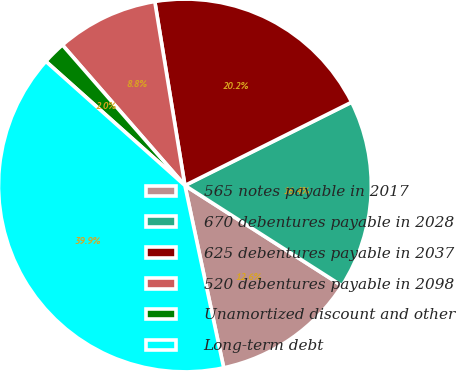Convert chart to OTSL. <chart><loc_0><loc_0><loc_500><loc_500><pie_chart><fcel>565 notes payable in 2017<fcel>670 debentures payable in 2028<fcel>625 debentures payable in 2037<fcel>520 debentures payable in 2098<fcel>Unamortized discount and other<fcel>Long-term debt<nl><fcel>12.62%<fcel>16.42%<fcel>20.21%<fcel>8.83%<fcel>1.99%<fcel>39.94%<nl></chart> 